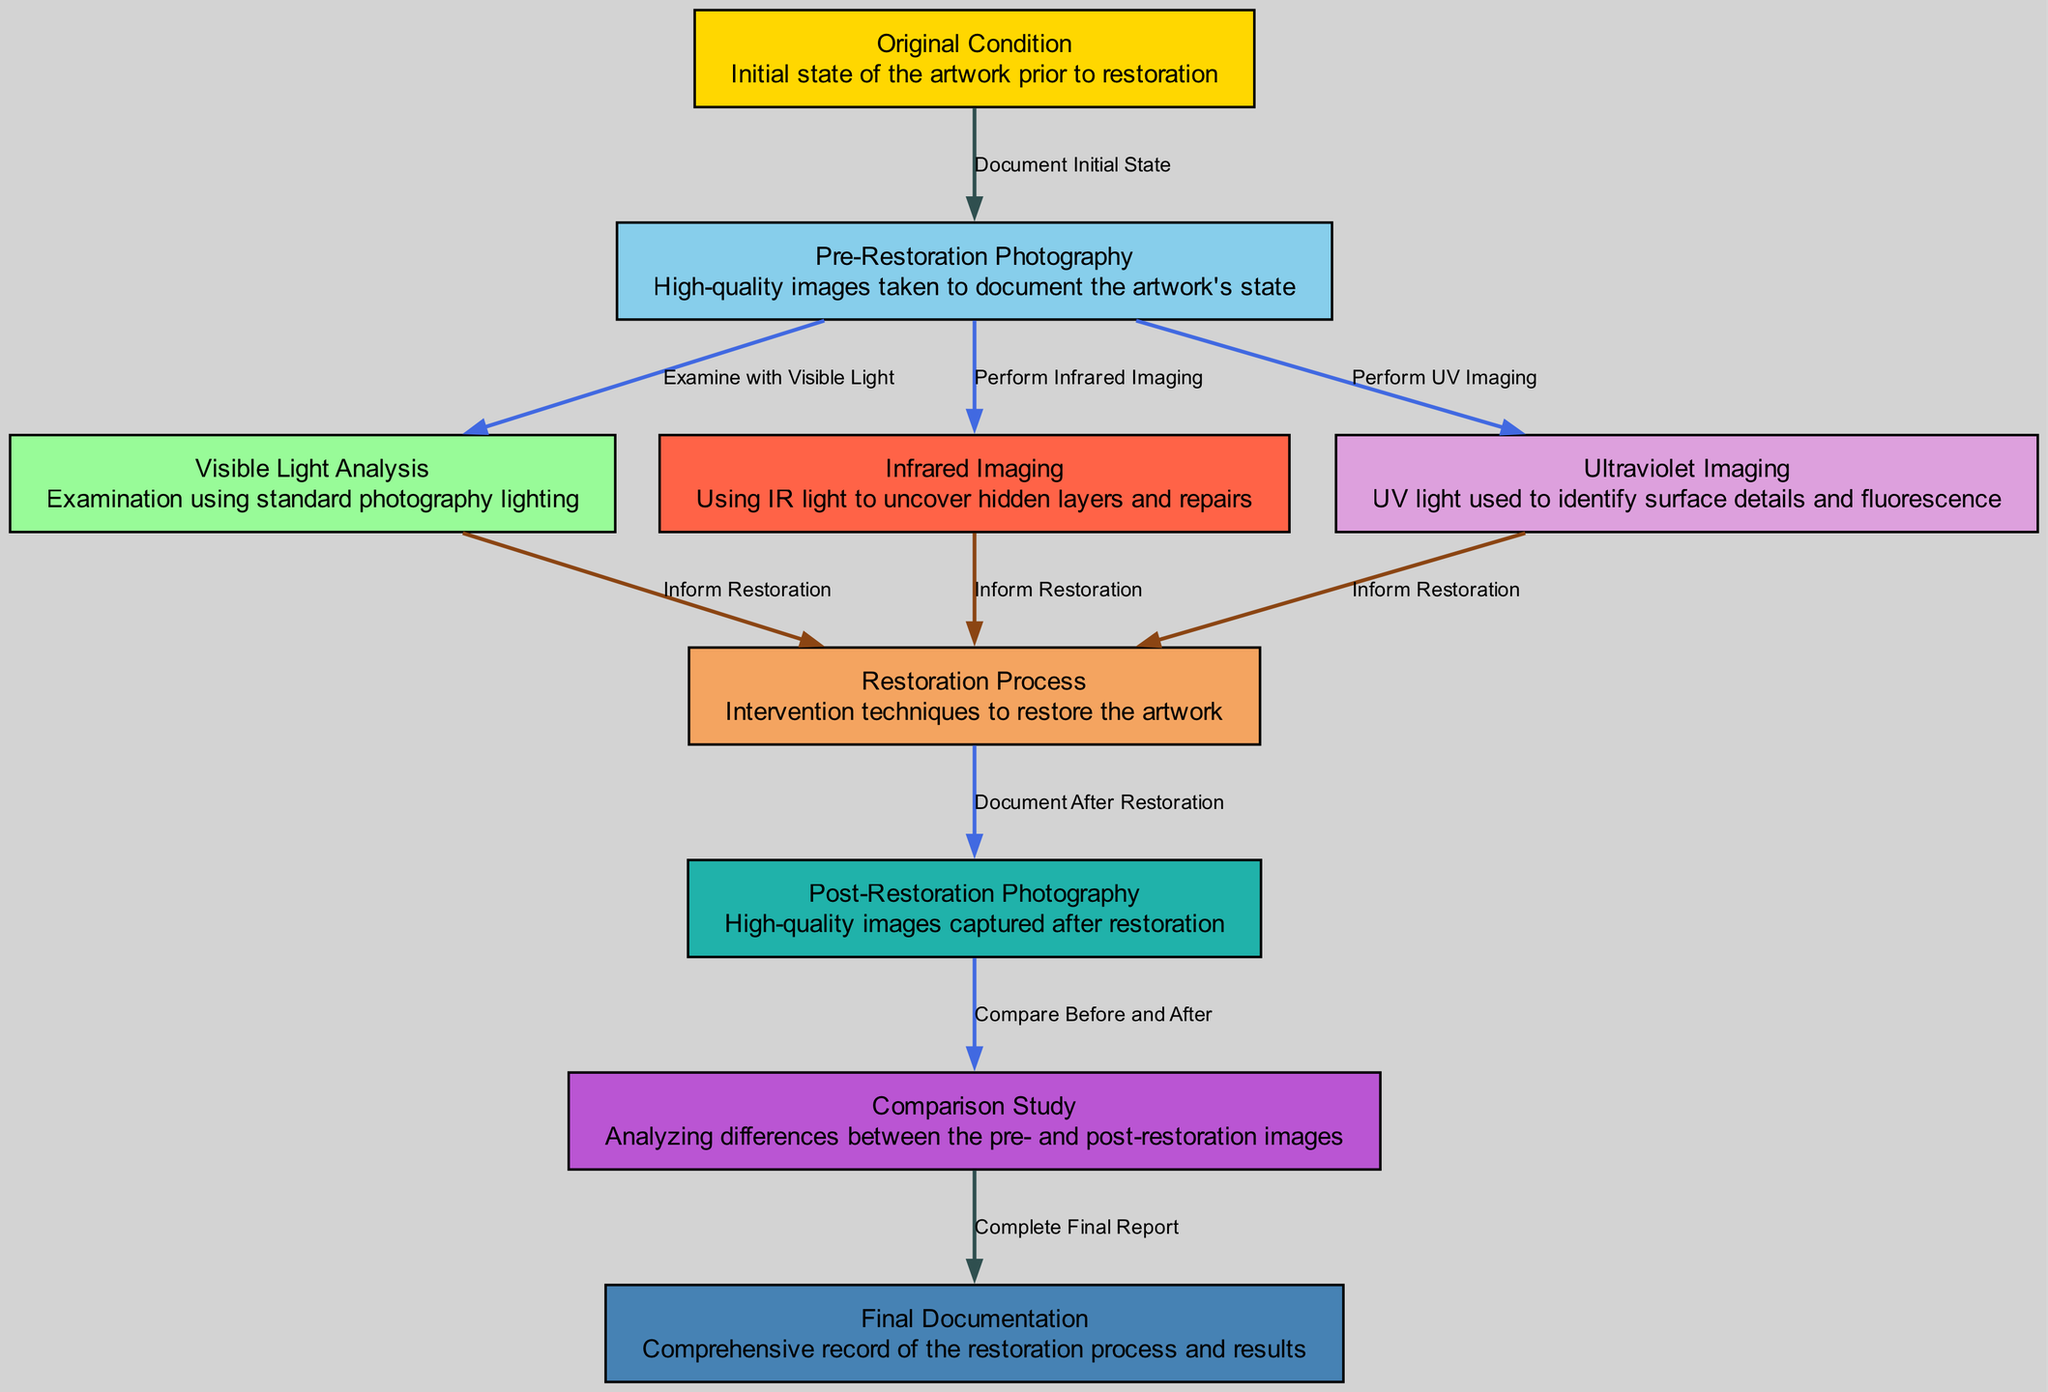What is the first node in the diagram? The first node, starting from the top, is labeled "Original Condition," which indicates the initial state of the artwork prior to restoration.
Answer: Original Condition How many nodes are present in the diagram? Counting all nodes listed, there are a total of 10 nodes in the diagram.
Answer: 10 What type of imaging follows pre-restoration photography? Pre-restoration photography leads to three branches of imaging: visible light analysis, infrared imaging, and ultraviolet imaging. Since infrared imaging is one of these, it is a valid answer.
Answer: Infrared Imaging Which node is linked to the post-restoration photography node? The post-restoration photography node flows from the restoration process node, which indicates that documentation occurs after the restoration is complete.
Answer: Restoration Process What is the last node in the diagram? The last node, which concludes the flow of the diagram, is labeled "Final Documentation," representing the comprehensive record after the analysis of the restoration results.
Answer: Final Documentation How does visible light analysis influence the restoration process? Visible light analysis provides information that informs the restoration process, indicating that the findings from this examination are used to guide restoration techniques.
Answer: Inform Restoration Which node has two types of imaging connected to it? The pre-restoration photography node has two types of imaging connected to it: infrared imaging and ultraviolet imaging, indicating it serves as the initial step that leads to multiple analyses.
Answer: Pre-Restoration Photography What is commonly compared in the comparison study node? The comparison study node focuses on analyzing the differences between pre-restoration and post-restoration images to evaluate the impact of the restoration.
Answer: Before and After What is the primary function of the final documentation node? The primary function of the final documentation node is to complete the final report, summarizing the entire restoration process and its results for record-keeping.
Answer: Complete Final Report 